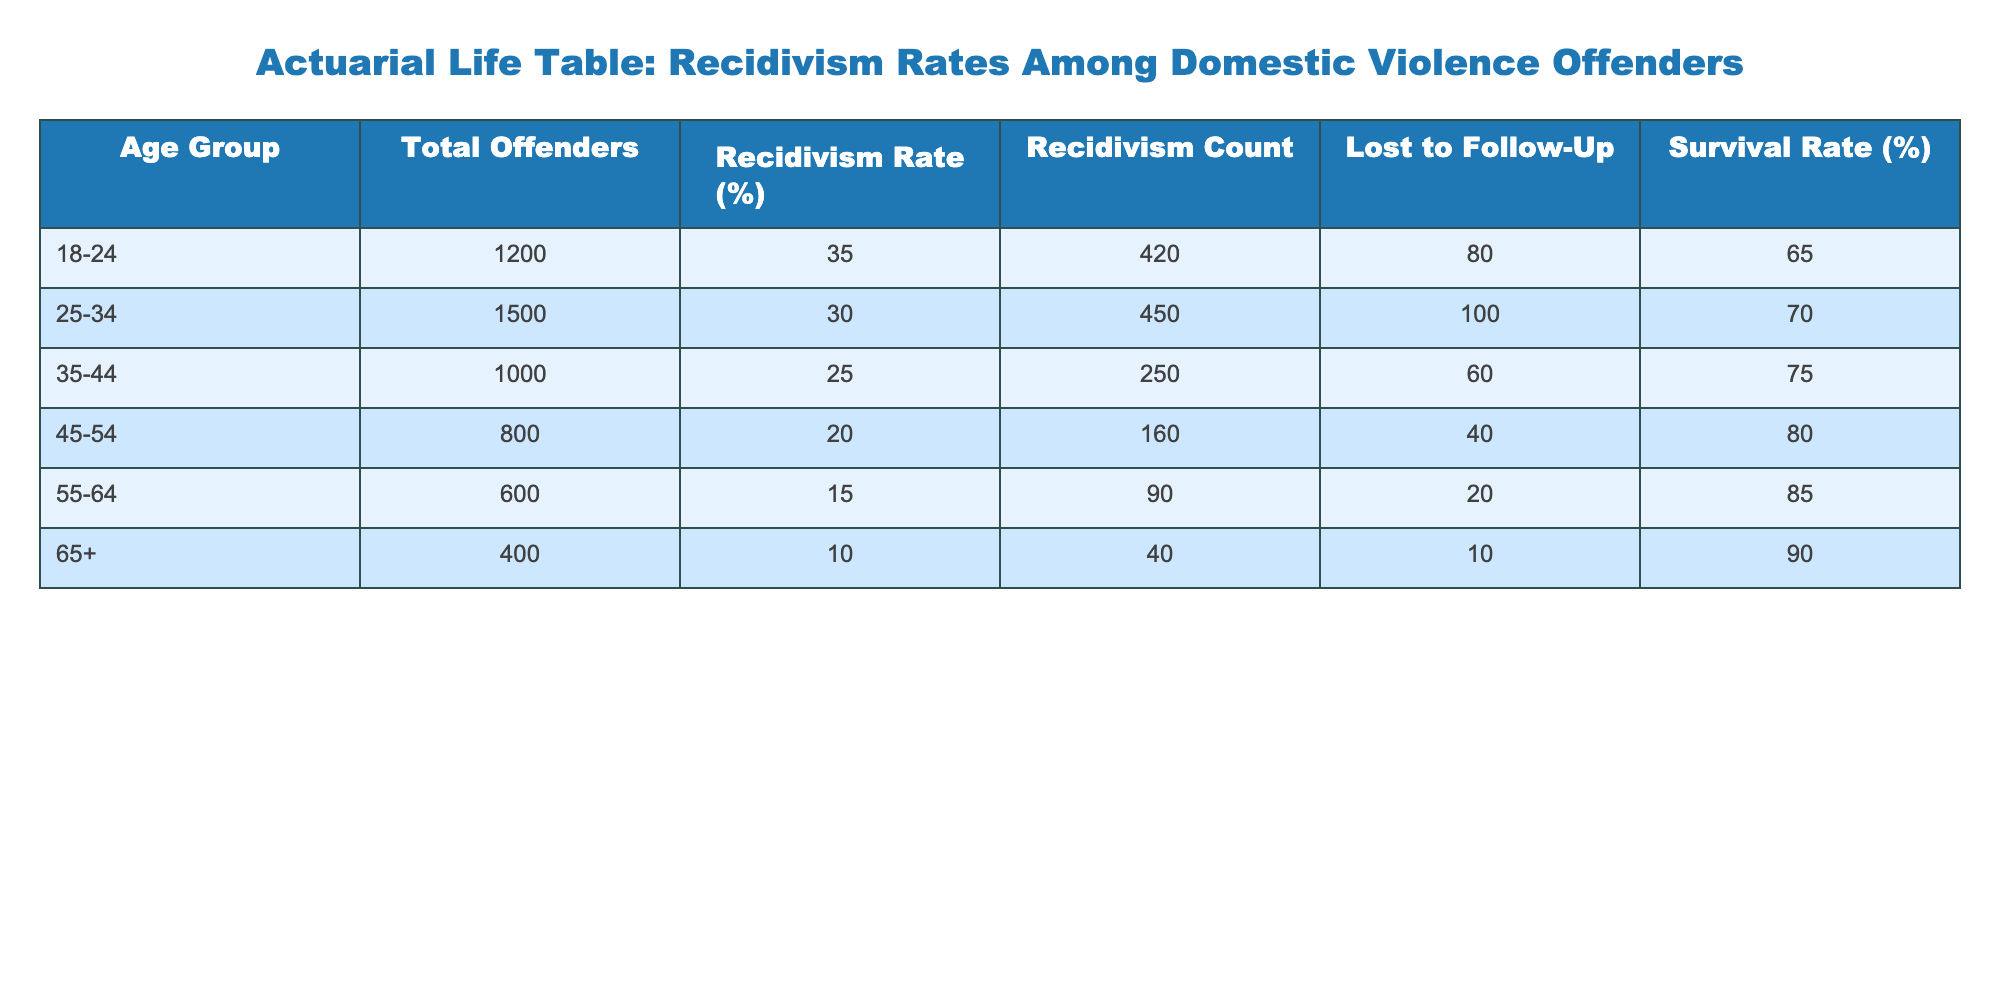What is the total number of offenders in the 18-24 age group? From the table, under the "Total Offenders" column for the 18-24 age group, the value is 1200. Therefore, the total number of offenders in this group is simply that value.
Answer: 1200 What is the recidivism rate for offenders aged 35-44? The table indicates that for the age group of 35-44, the recidivism rate is found under the "Recidivism Rate (%)" column, which shows a value of 25%.
Answer: 25% How many offenders were lost to follow-up in the 55-64 age group? Looking at the "Lost to Follow-Up" column for the 55-64 age group, the value is 20. This indicates the number of offenders that could not be followed up on in this group.
Answer: 20 What is the average recidivism rate across all age groups? To find the average, add all the recidivism rates: 35 + 30 + 25 + 20 + 15 + 10 = 135. Then, divide by the number of age groups, which is 6: 135 / 6 = 22.5. Therefore, the average recidivism rate is 22.5%.
Answer: 22.5% Is the survival rate for offenders aged 65 and older higher than for those aged 55-64? In the table, the survival rate for 65+ age group is 90%, while for the 55-64 age group, it's 85%. Since 90% is greater than 85%, the statement is true.
Answer: Yes What is the difference in recidivism counts between the 25-34 and 45-54 age groups? First, find the recidivism counts for both age groups: for 25-34 it is 450 and for 45-54 it is 160. The difference is calculated as 450 - 160 = 290. Thus, the difference in recidivism counts is 290.
Answer: 290 How many more total offenders are there in the 25-34 age group compared to the 55-64 age group? The total number of offenders in the 25-34 age group is 1500 and in the 55-64 age group is 600. To find the difference, perform the calculation: 1500 - 600 = 900. Therefore, there are 900 more total offenders in the younger age group.
Answer: 900 What is the total number of offenders across all age groups? Summing the "Total Offenders" across all the age groups gives: 1200 + 1500 + 1000 + 800 + 600 + 400 = 4500. Thus, the total number of offenders is 4500.
Answer: 4500 